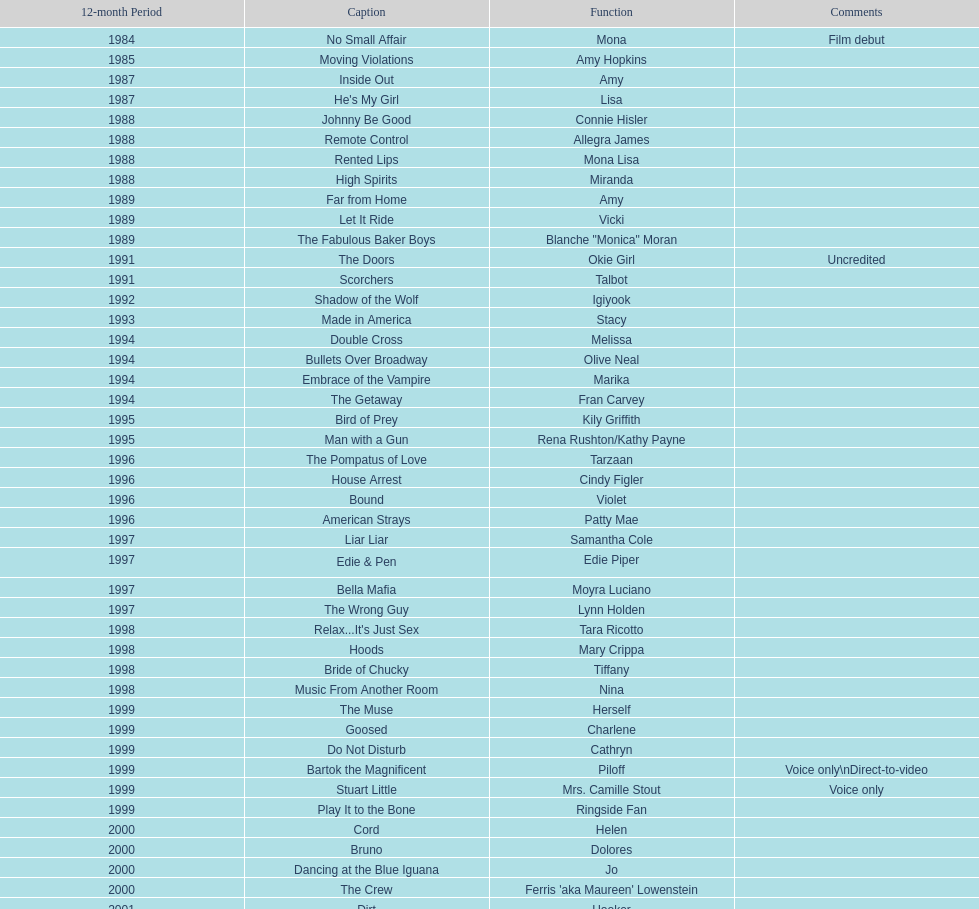Could you help me parse every detail presented in this table? {'header': ['12-month Period', 'Caption', 'Function', 'Comments'], 'rows': [['1984', 'No Small Affair', 'Mona', 'Film debut'], ['1985', 'Moving Violations', 'Amy Hopkins', ''], ['1987', 'Inside Out', 'Amy', ''], ['1987', "He's My Girl", 'Lisa', ''], ['1988', 'Johnny Be Good', 'Connie Hisler', ''], ['1988', 'Remote Control', 'Allegra James', ''], ['1988', 'Rented Lips', 'Mona Lisa', ''], ['1988', 'High Spirits', 'Miranda', ''], ['1989', 'Far from Home', 'Amy', ''], ['1989', 'Let It Ride', 'Vicki', ''], ['1989', 'The Fabulous Baker Boys', 'Blanche "Monica" Moran', ''], ['1991', 'The Doors', 'Okie Girl', 'Uncredited'], ['1991', 'Scorchers', 'Talbot', ''], ['1992', 'Shadow of the Wolf', 'Igiyook', ''], ['1993', 'Made in America', 'Stacy', ''], ['1994', 'Double Cross', 'Melissa', ''], ['1994', 'Bullets Over Broadway', 'Olive Neal', ''], ['1994', 'Embrace of the Vampire', 'Marika', ''], ['1994', 'The Getaway', 'Fran Carvey', ''], ['1995', 'Bird of Prey', 'Kily Griffith', ''], ['1995', 'Man with a Gun', 'Rena Rushton/Kathy Payne', ''], ['1996', 'The Pompatus of Love', 'Tarzaan', ''], ['1996', 'House Arrest', 'Cindy Figler', ''], ['1996', 'Bound', 'Violet', ''], ['1996', 'American Strays', 'Patty Mae', ''], ['1997', 'Liar Liar', 'Samantha Cole', ''], ['1997', 'Edie & Pen', 'Edie Piper', ''], ['1997', 'Bella Mafia', 'Moyra Luciano', ''], ['1997', 'The Wrong Guy', 'Lynn Holden', ''], ['1998', "Relax...It's Just Sex", 'Tara Ricotto', ''], ['1998', 'Hoods', 'Mary Crippa', ''], ['1998', 'Bride of Chucky', 'Tiffany', ''], ['1998', 'Music From Another Room', 'Nina', ''], ['1999', 'The Muse', 'Herself', ''], ['1999', 'Goosed', 'Charlene', ''], ['1999', 'Do Not Disturb', 'Cathryn', ''], ['1999', 'Bartok the Magnificent', 'Piloff', 'Voice only\\nDirect-to-video'], ['1999', 'Stuart Little', 'Mrs. Camille Stout', 'Voice only'], ['1999', 'Play It to the Bone', 'Ringside Fan', ''], ['2000', 'Cord', 'Helen', ''], ['2000', 'Bruno', 'Dolores', ''], ['2000', 'Dancing at the Blue Iguana', 'Jo', ''], ['2000', 'The Crew', "Ferris 'aka Maureen' Lowenstein", ''], ['2001', 'Dirt', 'Hooker', ''], ['2001', 'Fast Sofa', 'Ginger Quail', ''], ['2001', 'Monsters, Inc.', 'Celia Mae', 'Voice only'], ['2001', 'Ball in the House', 'Dot', ''], ['2001', "The Cat's Meow", 'Louella Parsons', ''], ['2003', 'Hollywood North', 'Gillian Stevens', ''], ['2003', 'The Haunted Mansion', 'Madame Leota', ''], ['2003', 'Happy End', 'Edna', ''], ['2003', 'Jericho Mansions', 'Donna Cherry', ''], ['2004', 'Second Best', 'Carole', ''], ['2004', 'Perfect Opposites', 'Elyse Steinberg', ''], ['2004', 'Home on the Range', 'Grace', 'Voice only'], ['2004', 'El Padrino', 'Sebeva', ''], ['2004', 'Saint Ralph', 'Nurse Alice', ''], ['2004', 'Love on the Side', 'Alma Kerns', ''], ['2004', 'Seed of Chucky', 'Tiffany/Herself', ''], ['2005', "Bailey's Billion$", 'Dolores Pennington', ''], ['2005', "Lil' Pimp", 'Miss De La Croix', 'Voice only'], ['2005', 'The Civilization of Maxwell Bright', "Dr. O'Shannon", ''], ['2005', 'Tideland', 'Queen Gunhilda', ''], ['2006', 'The Poker Movie', 'Herself', ''], ['2007', 'Intervention', '', ''], ['2008', 'Deal', "Karen 'Razor' Jones", ''], ['2008', 'The Caretaker', 'Miss Perry', ''], ['2008', 'Bart Got a Room', 'Melinda', ''], ['2008', 'Inconceivable', "Salome 'Sally' Marsh", ''], ['2009', 'An American Girl: Chrissa Stands Strong', 'Mrs. Rundell', ''], ['2009', 'Imps', '', ''], ['2009', 'Made in Romania', 'Herself', ''], ['2009', 'Empire of Silver', 'Mrs. Landdeck', ''], ['2010', 'The Making of Plus One', 'Amber', ''], ['2010', 'The Secret Lives of Dorks', 'Ms. Stewart', ''], ['2012', '30 Beats', 'Erika', ''], ['2013', 'Curse of Chucky', 'Tiffany Ray', 'Cameo, Direct-to-video']]} How many films does jennifer tilly do a voice over role in? 5. 